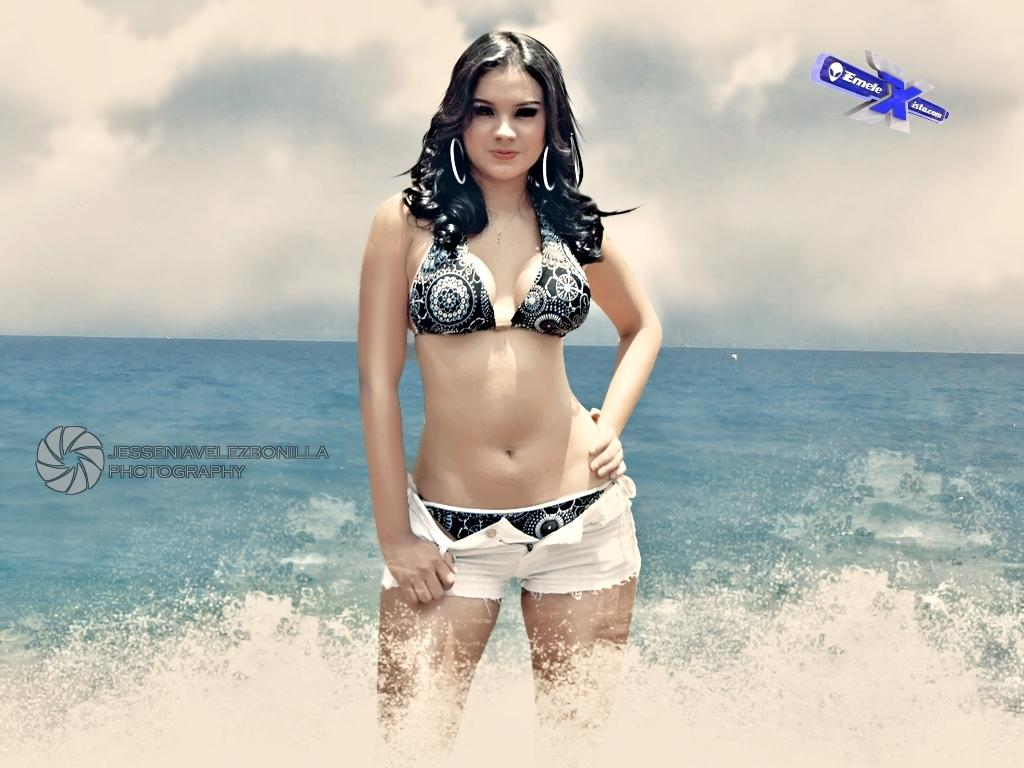What is featured in the image? There is a poster and a woman standing in the center of the image. What can be seen in the background of the image? There is water visible in the image, and the sky is visible at the top of the image. What type of toys can be seen in the woman's hands in the image? There are no toys present in the image; the woman is not holding anything in her hands. 